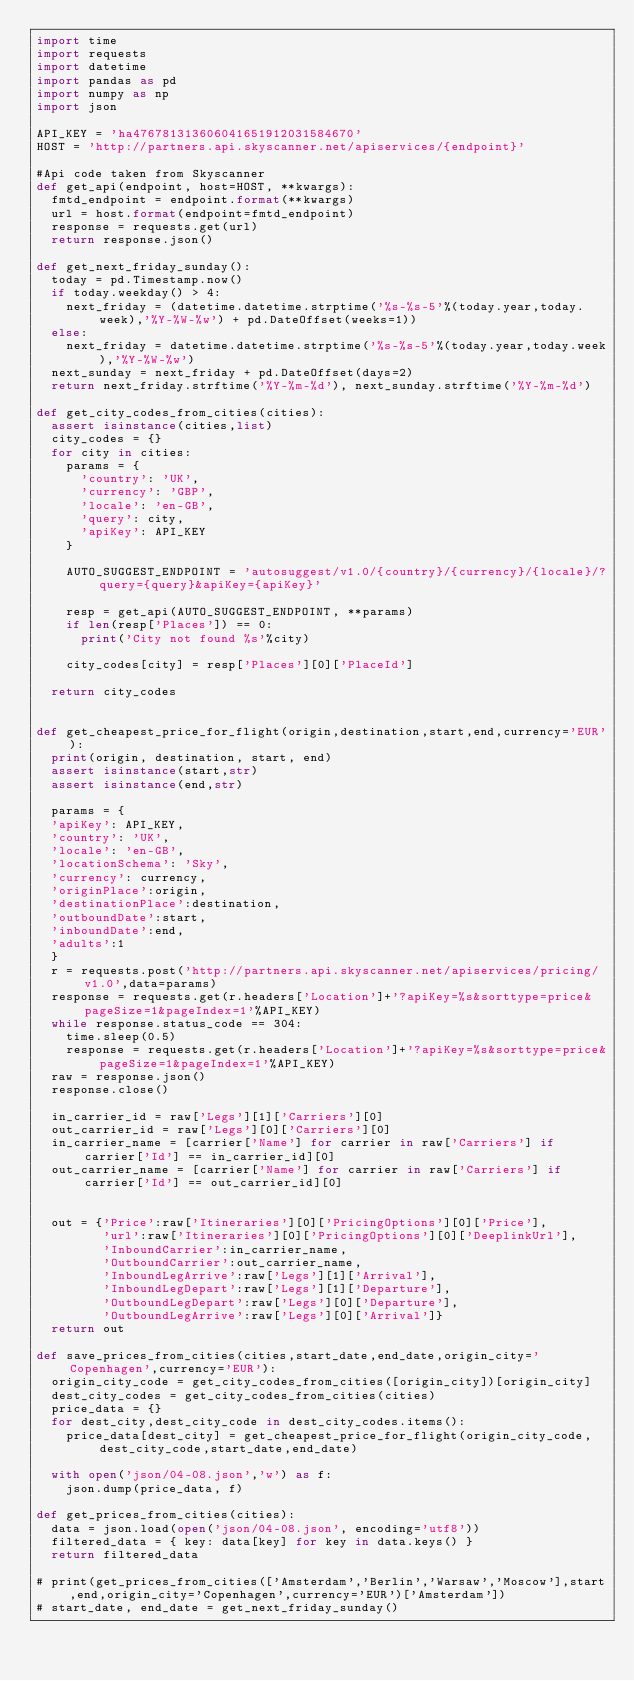Convert code to text. <code><loc_0><loc_0><loc_500><loc_500><_Python_>import time
import requests
import datetime
import pandas as pd
import numpy as np
import json

API_KEY = 'ha476781313606041651912031584670'
HOST = 'http://partners.api.skyscanner.net/apiservices/{endpoint}'

#Api code taken from Skyscanner
def get_api(endpoint, host=HOST, **kwargs):
  fmtd_endpoint = endpoint.format(**kwargs)
  url = host.format(endpoint=fmtd_endpoint)
  response = requests.get(url)
  return response.json()

def get_next_friday_sunday():
  today = pd.Timestamp.now()
  if today.weekday() > 4:
    next_friday = (datetime.datetime.strptime('%s-%s-5'%(today.year,today.week),'%Y-%W-%w') + pd.DateOffset(weeks=1))
  else:
    next_friday = datetime.datetime.strptime('%s-%s-5'%(today.year,today.week),'%Y-%W-%w')
  next_sunday = next_friday + pd.DateOffset(days=2)
  return next_friday.strftime('%Y-%m-%d'), next_sunday.strftime('%Y-%m-%d')

def get_city_codes_from_cities(cities):
  assert isinstance(cities,list)
  city_codes = {}
  for city in cities:
    params = {
      'country': 'UK',
      'currency': 'GBP',
      'locale': 'en-GB',
      'query': city,
      'apiKey': API_KEY
    }

    AUTO_SUGGEST_ENDPOINT = 'autosuggest/v1.0/{country}/{currency}/{locale}/?query={query}&apiKey={apiKey}'

    resp = get_api(AUTO_SUGGEST_ENDPOINT, **params)
    if len(resp['Places']) == 0:
      print('City not found %s'%city)
    
    city_codes[city] = resp['Places'][0]['PlaceId']
        
  return city_codes


def get_cheapest_price_for_flight(origin,destination,start,end,currency='EUR'):
  print(origin, destination, start, end)
  assert isinstance(start,str)
  assert isinstance(end,str)
  
  params = {
  'apiKey': API_KEY,
  'country': 'UK',
  'locale': 'en-GB',
  'locationSchema': 'Sky',
  'currency': currency,
  'originPlace':origin,
  'destinationPlace':destination,
  'outboundDate':start,
  'inboundDate':end,
  'adults':1
  }
  r = requests.post('http://partners.api.skyscanner.net/apiservices/pricing/v1.0',data=params)
  response = requests.get(r.headers['Location']+'?apiKey=%s&sorttype=price&pageSize=1&pageIndex=1'%API_KEY)
  while response.status_code == 304:
    time.sleep(0.5)
    response = requests.get(r.headers['Location']+'?apiKey=%s&sorttype=price&pageSize=1&pageIndex=1'%API_KEY)
  raw = response.json()
  response.close()
  
  in_carrier_id = raw['Legs'][1]['Carriers'][0]
  out_carrier_id = raw['Legs'][0]['Carriers'][0]
  in_carrier_name = [carrier['Name'] for carrier in raw['Carriers'] if carrier['Id'] == in_carrier_id][0]
  out_carrier_name = [carrier['Name'] for carrier in raw['Carriers'] if carrier['Id'] == out_carrier_id][0]
 
  
  out = {'Price':raw['Itineraries'][0]['PricingOptions'][0]['Price'],
         'url':raw['Itineraries'][0]['PricingOptions'][0]['DeeplinkUrl'],
         'InboundCarrier':in_carrier_name,
         'OutboundCarrier':out_carrier_name,
         'InboundLegArrive':raw['Legs'][1]['Arrival'],
         'InboundLegDepart':raw['Legs'][1]['Departure'],
         'OutboundLegDepart':raw['Legs'][0]['Departure'],
         'OutboundLegArrive':raw['Legs'][0]['Arrival']}
  return out

def save_prices_from_cities(cities,start_date,end_date,origin_city='Copenhagen',currency='EUR'):
  origin_city_code = get_city_codes_from_cities([origin_city])[origin_city]
  dest_city_codes = get_city_codes_from_cities(cities)
  price_data = {}
  for dest_city,dest_city_code in dest_city_codes.items():
    price_data[dest_city] = get_cheapest_price_for_flight(origin_city_code,dest_city_code,start_date,end_date)

  with open('json/04-08.json','w') as f:
    json.dump(price_data, f)

def get_prices_from_cities(cities):
  data = json.load(open('json/04-08.json', encoding='utf8'))
  filtered_data = { key: data[key] for key in data.keys() }
  return filtered_data

# print(get_prices_from_cities(['Amsterdam','Berlin','Warsaw','Moscow'],start,end,origin_city='Copenhagen',currency='EUR')['Amsterdam'])
# start_date, end_date = get_next_friday_sunday()</code> 